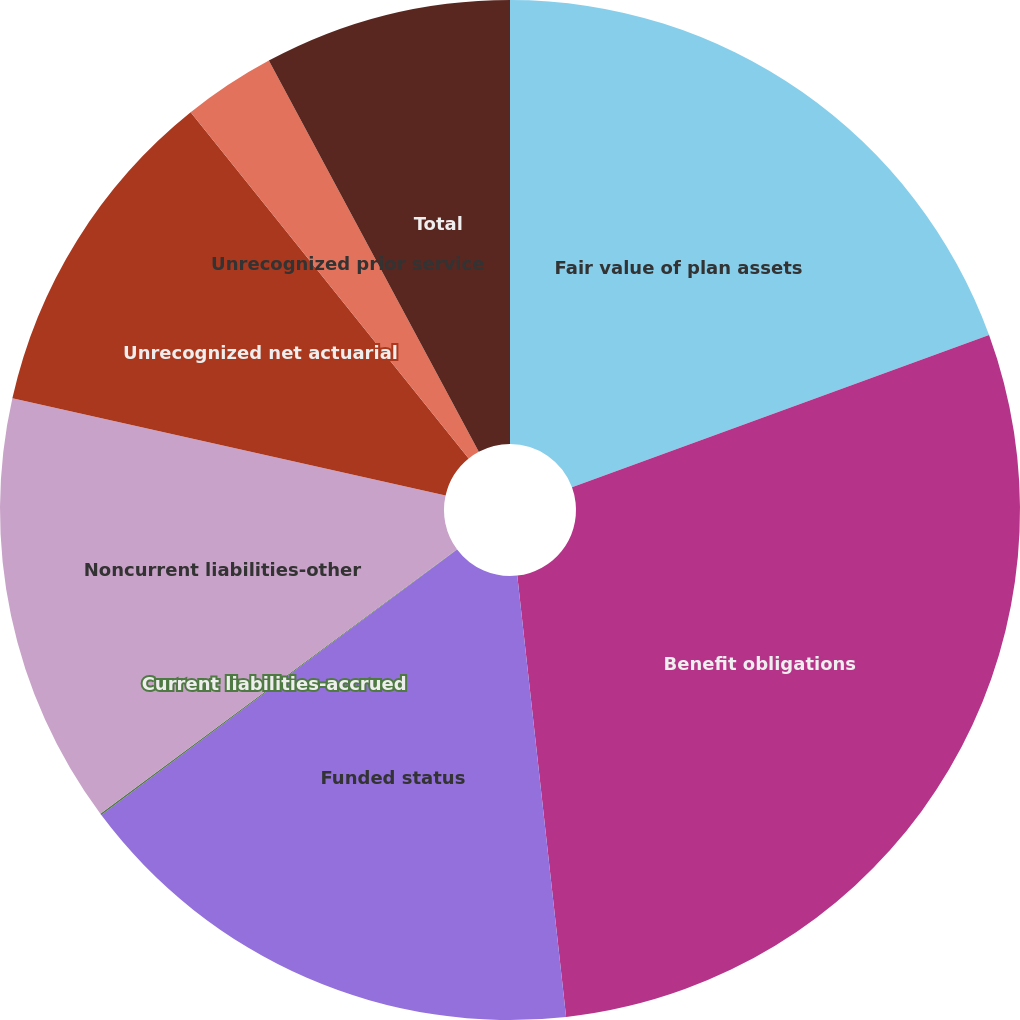Convert chart. <chart><loc_0><loc_0><loc_500><loc_500><pie_chart><fcel>Fair value of plan assets<fcel>Benefit obligations<fcel>Funded status<fcel>Current liabilities-accrued<fcel>Noncurrent liabilities-other<fcel>Unrecognized net actuarial<fcel>Unrecognized prior service<fcel>Total<nl><fcel>19.43%<fcel>28.82%<fcel>16.55%<fcel>0.05%<fcel>13.67%<fcel>10.72%<fcel>2.93%<fcel>7.84%<nl></chart> 